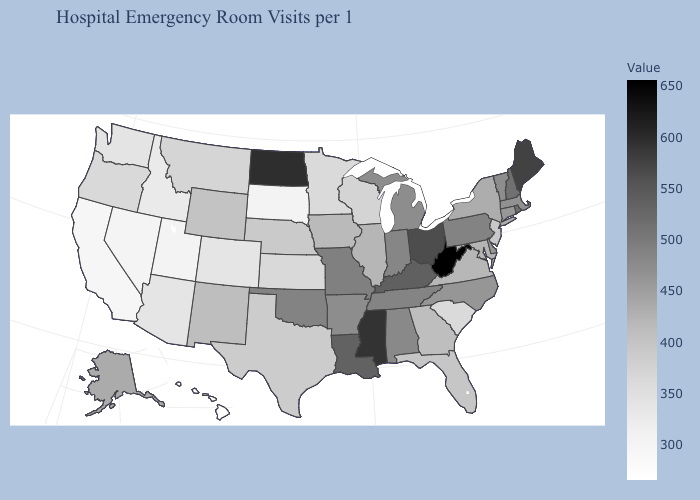Among the states that border Rhode Island , does Massachusetts have the lowest value?
Write a very short answer. No. Which states have the lowest value in the South?
Keep it brief. South Carolina. Which states have the highest value in the USA?
Keep it brief. West Virginia. Which states hav the highest value in the Northeast?
Short answer required. Maine. 